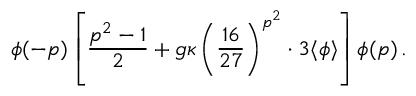<formula> <loc_0><loc_0><loc_500><loc_500>\phi ( - p ) \left [ \frac { p ^ { 2 } - 1 } { 2 } + g \kappa \left ( \frac { 1 6 } { 2 7 } \right ) ^ { p ^ { 2 } } \cdot 3 \langle \phi \rangle \right ] \phi ( p ) \, .</formula> 